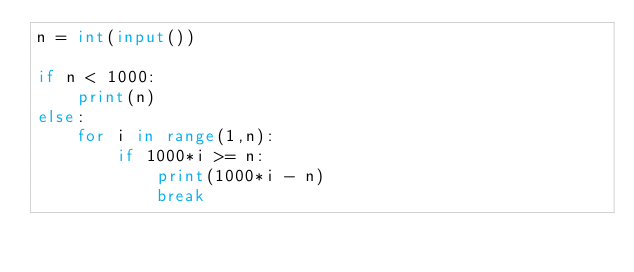Convert code to text. <code><loc_0><loc_0><loc_500><loc_500><_Python_>n = int(input())

if n < 1000:
    print(n)
else:
    for i in range(1,n):
        if 1000*i >= n:
            print(1000*i - n)
            break</code> 